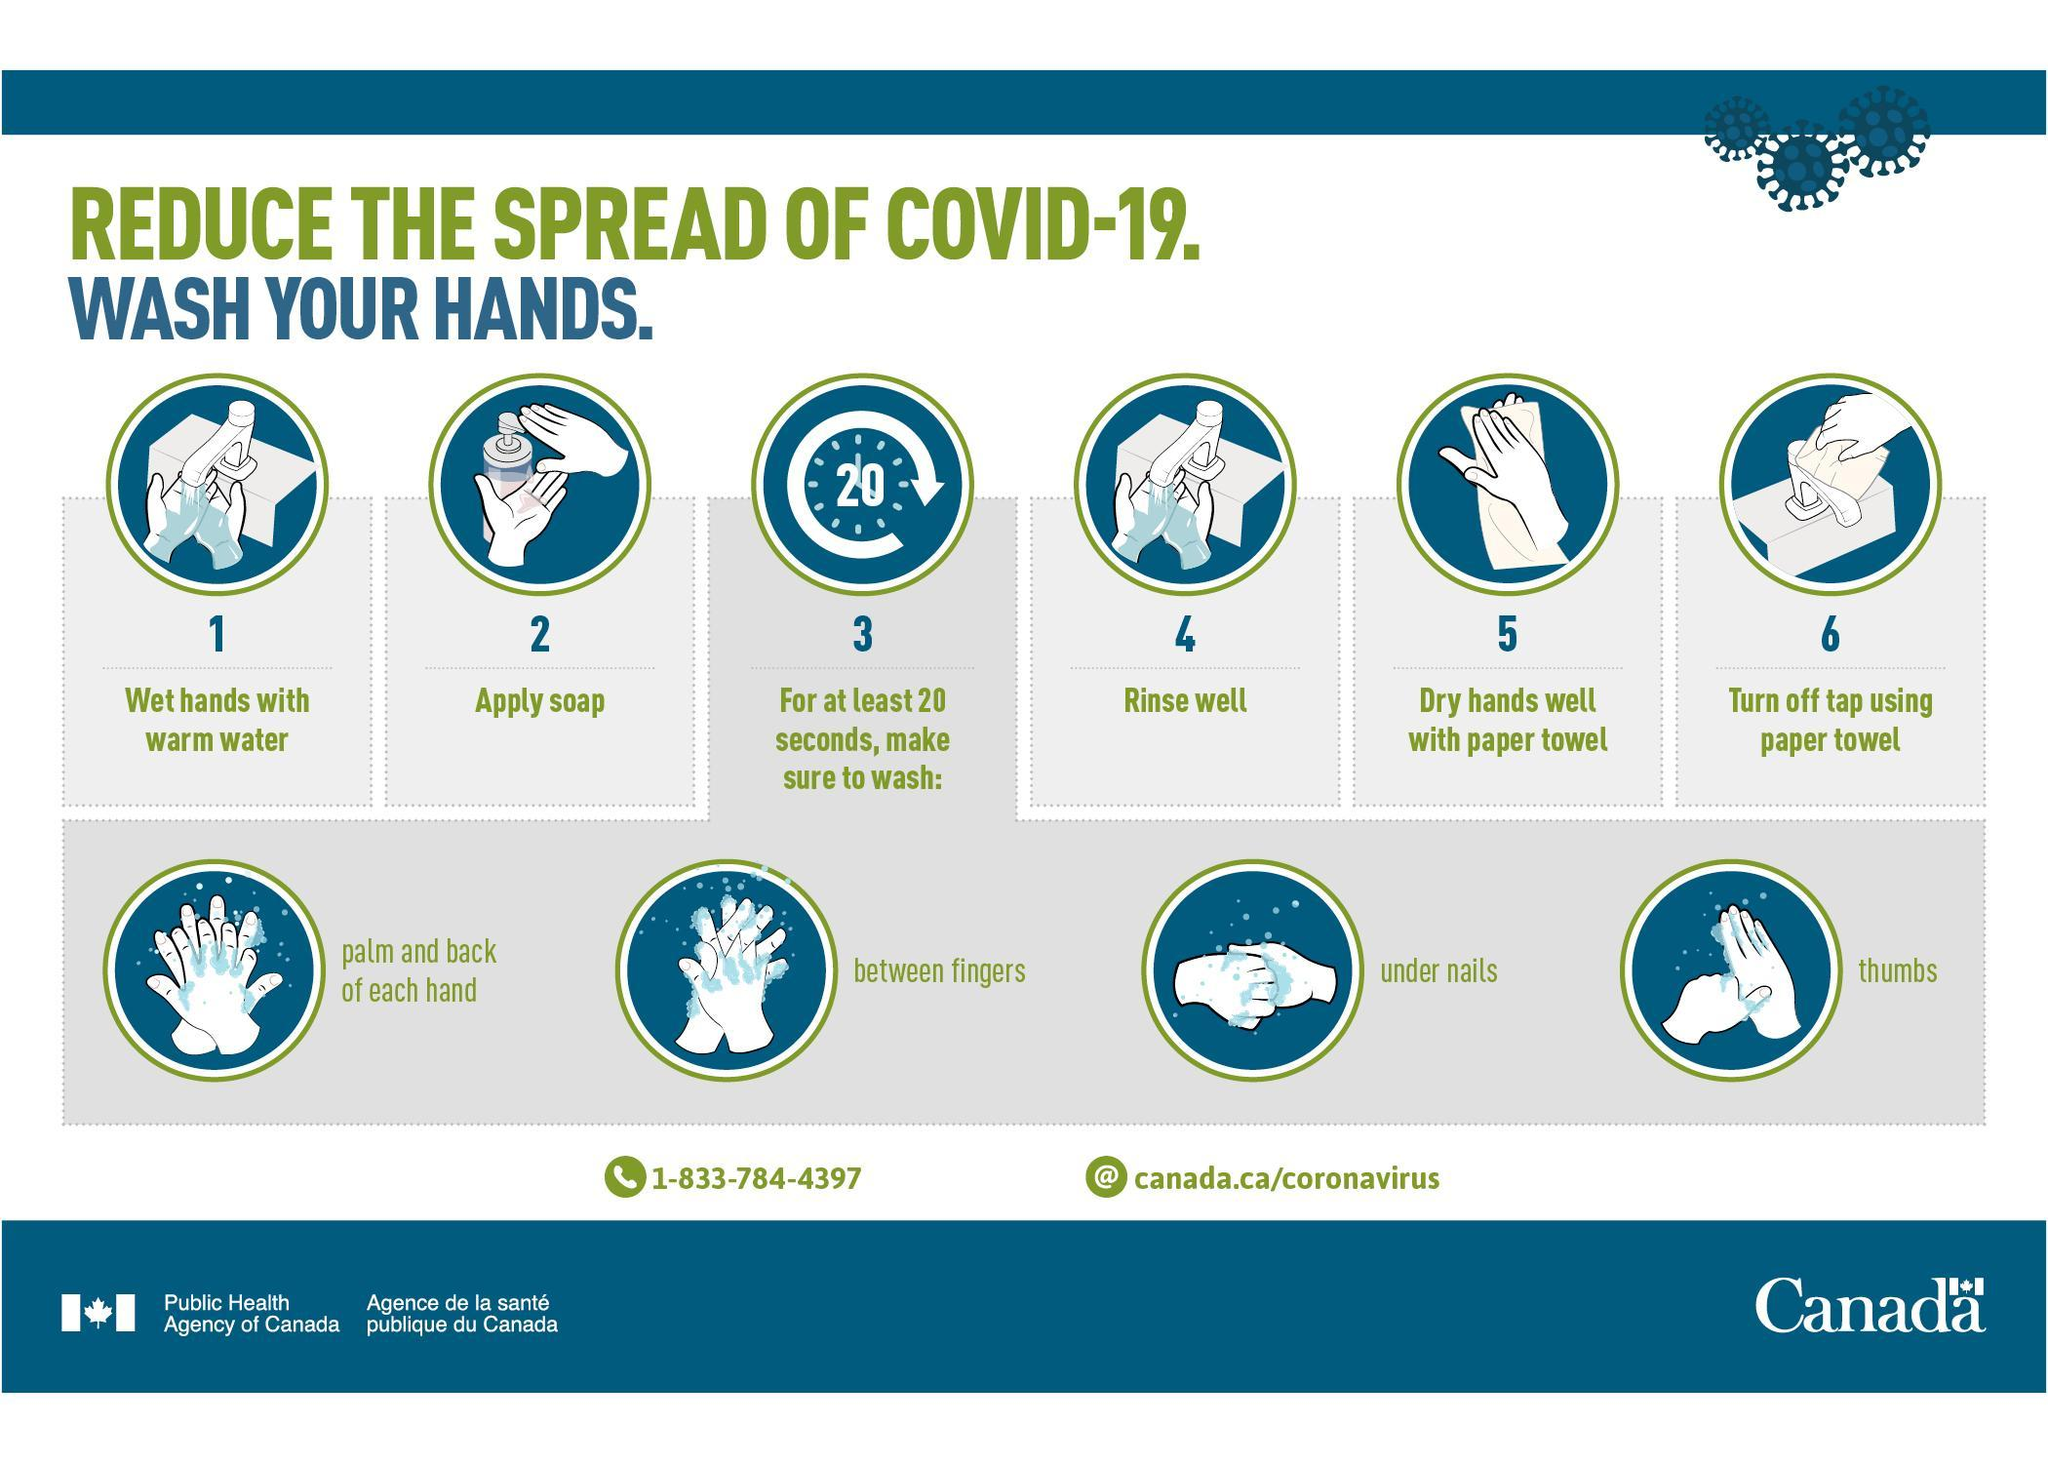How long one should wash their hands in order to reduce the spread of COVID-19?
Answer the question with a short phrase. for at least 20 seconds 